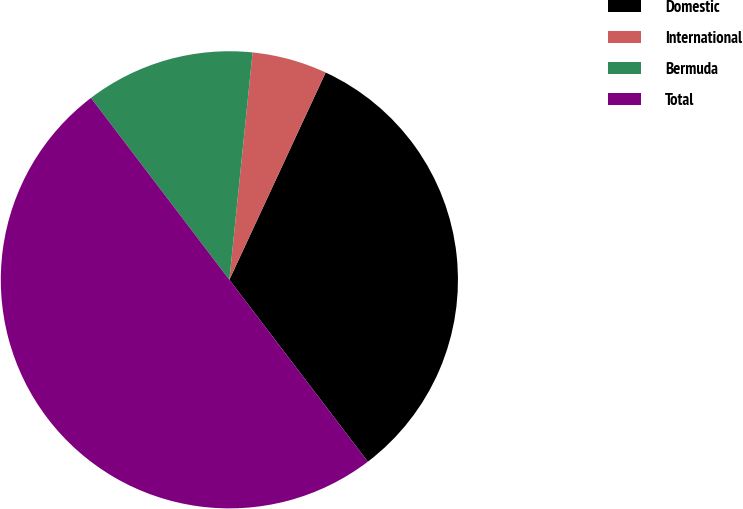Convert chart. <chart><loc_0><loc_0><loc_500><loc_500><pie_chart><fcel>Domestic<fcel>International<fcel>Bermuda<fcel>Total<nl><fcel>32.72%<fcel>5.3%<fcel>11.97%<fcel>50.0%<nl></chart> 